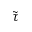Convert formula to latex. <formula><loc_0><loc_0><loc_500><loc_500>\tilde { \tau }</formula> 